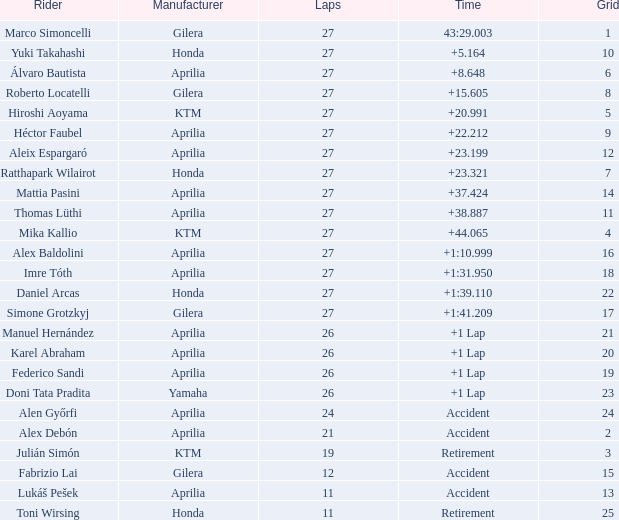Which Manufacturer has a Time of accident and a Grid greater than 15? Aprilia. 